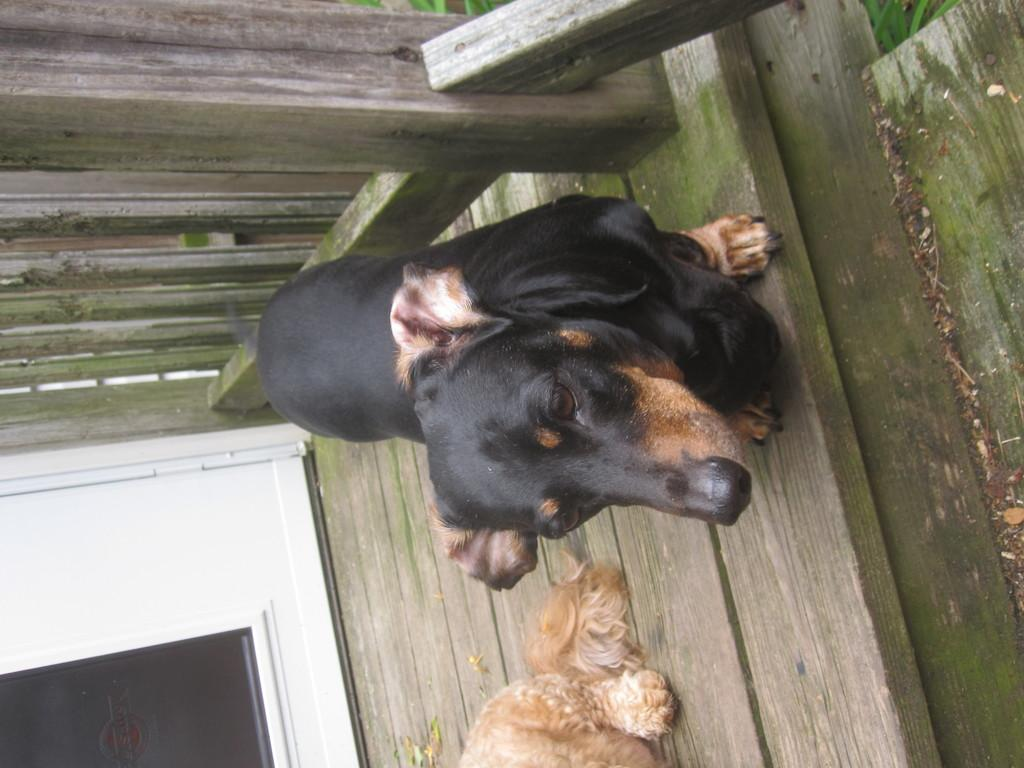What animals are present in the image? There are dogs in the image. Where are the dogs located? The dogs are sitting on a deck. What is visible on the left side of the image? There is a door on the left side of the image. What type of vest can be seen on the dogs in the image? There are no vests visible on the dogs in the image. Can you tell me how many volcanoes are present in the image? There are no volcanoes present in the image. What type of cover is protecting the dogs from the sun in the image? There is no cover visible in the image to protect the dogs from the sun. 